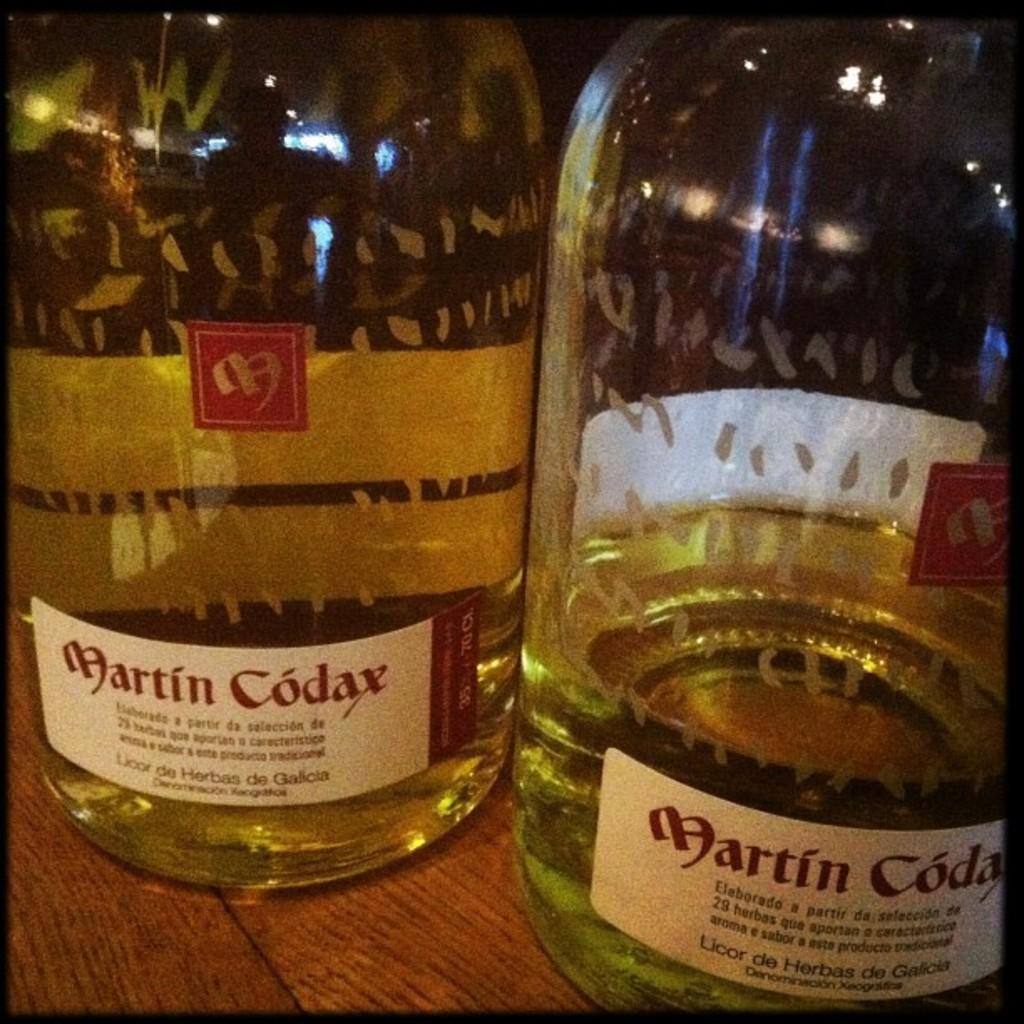<image>
Offer a succinct explanation of the picture presented. Two bottles of Martin Codax sitting on a wood table. 